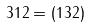<formula> <loc_0><loc_0><loc_500><loc_500>3 1 2 = ( 1 3 2 )</formula> 